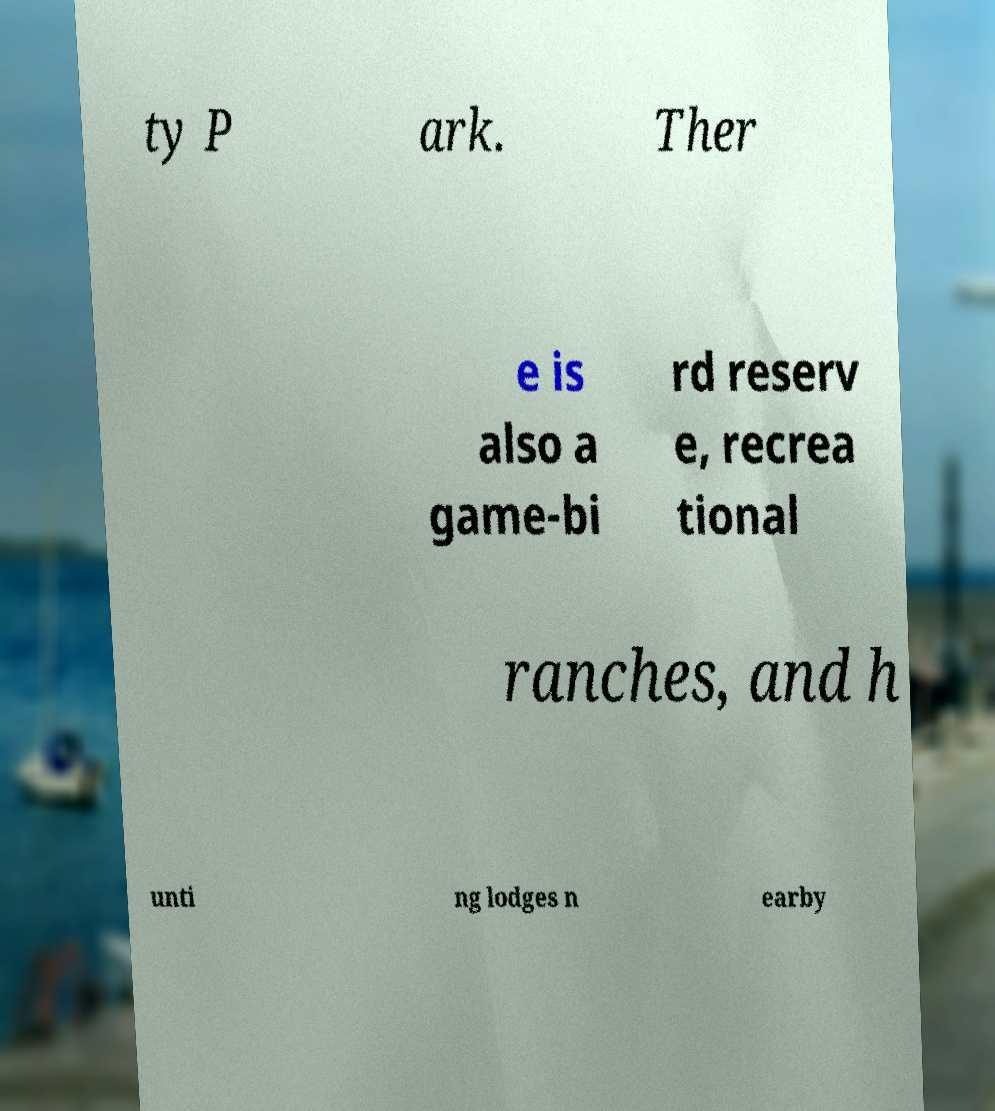Can you accurately transcribe the text from the provided image for me? ty P ark. Ther e is also a game-bi rd reserv e, recrea tional ranches, and h unti ng lodges n earby 